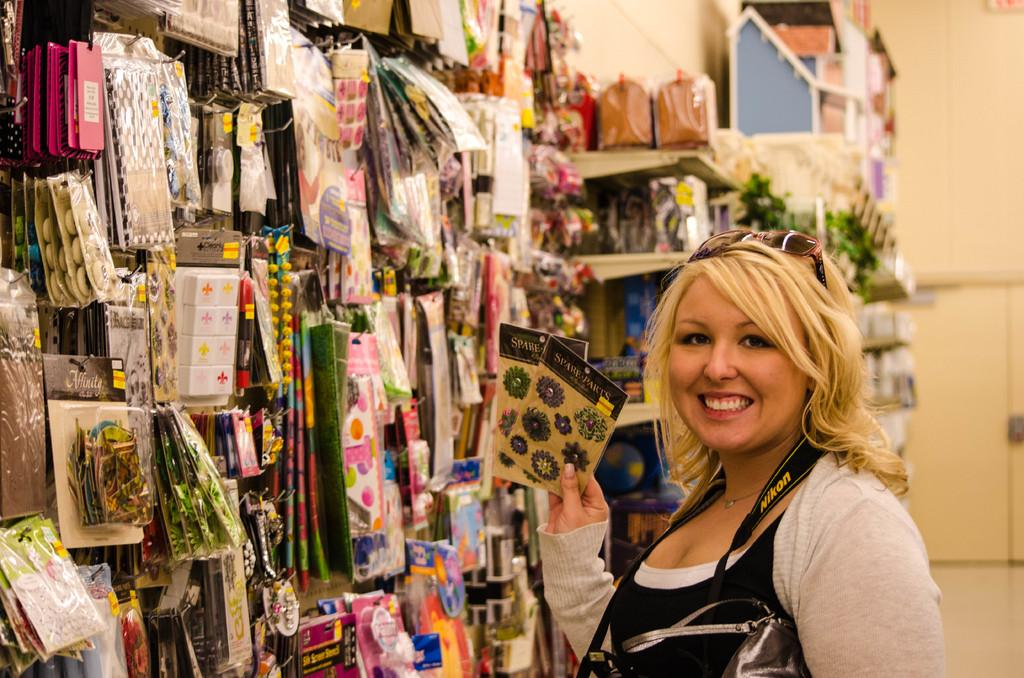Who is present in the image? There is a woman in the image. What is the woman wearing? The woman is wearing a camera. What can be seen in the middle of the image? There are decorative items in the middle of the image. How many goldfish are swimming in the image? There are no goldfish present in the image. What type of property can be seen in the background of the image? There is no property visible in the image; it only features the woman, her camera, and the decorative items. 